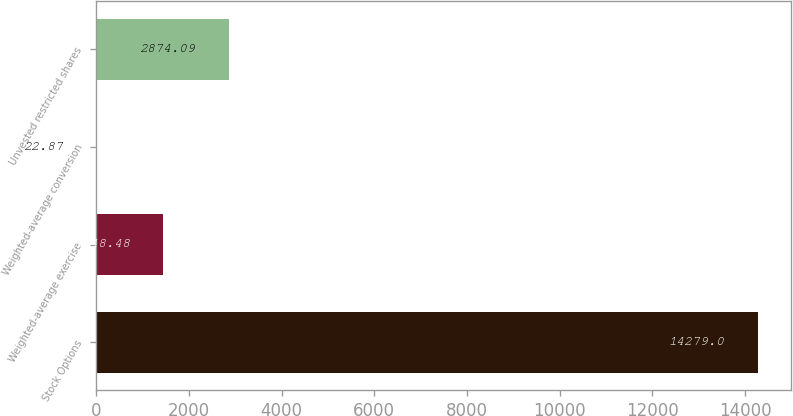Convert chart. <chart><loc_0><loc_0><loc_500><loc_500><bar_chart><fcel>Stock Options<fcel>Weighted-average exercise<fcel>Weighted-average conversion<fcel>Unvested restricted shares<nl><fcel>14279<fcel>1448.48<fcel>22.87<fcel>2874.09<nl></chart> 